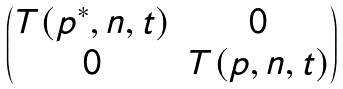<formula> <loc_0><loc_0><loc_500><loc_500>\begin{pmatrix} T ( p ^ { \ast } , n , t ) & 0 \\ 0 & T ( p , n , t ) \end{pmatrix}</formula> 